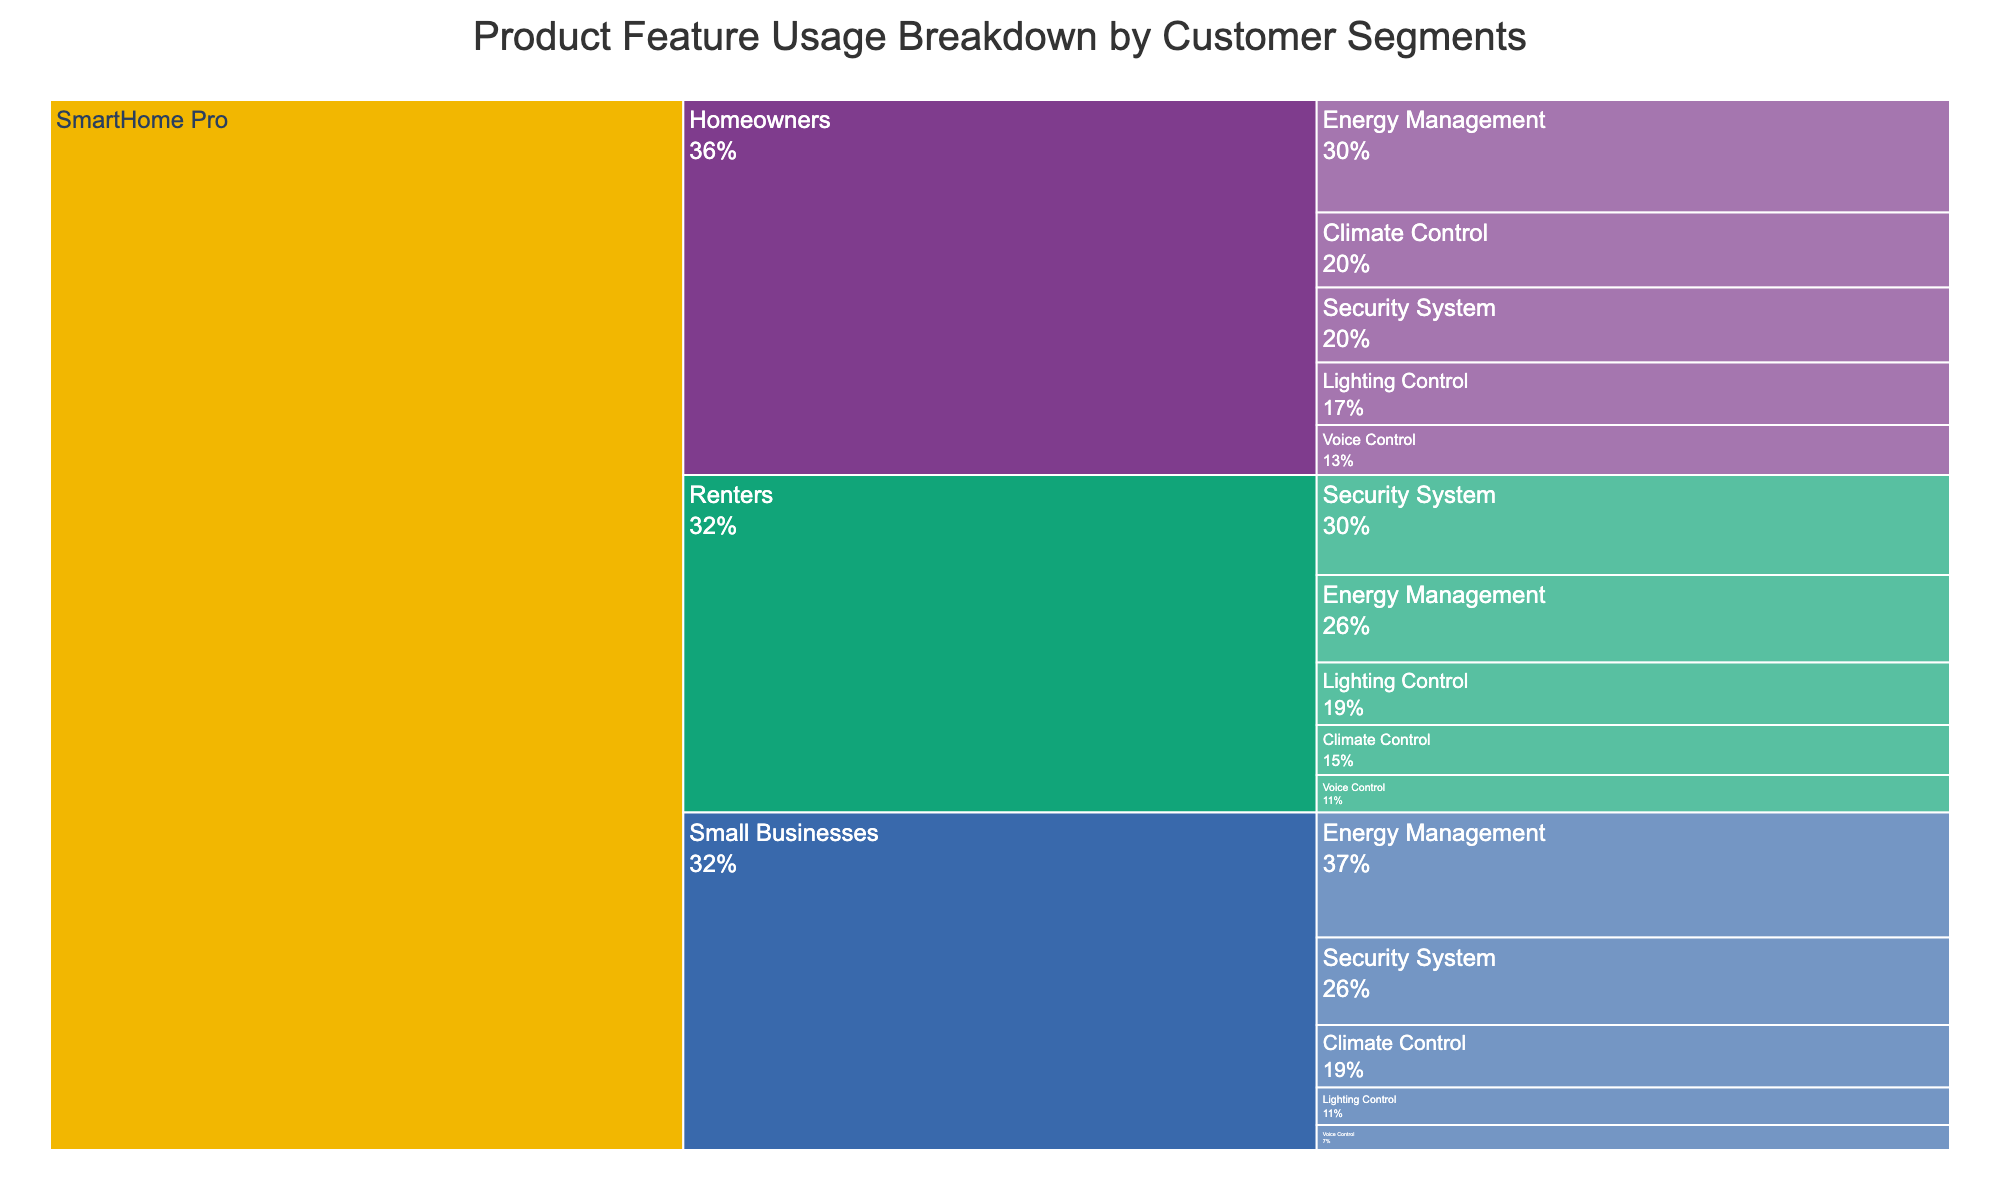What's the title of the chart? The title is usually displayed at the top of the chart and provides a summary of what the chart is about.
Answer: Product Feature Usage Breakdown by Customer Segments How many different segments are shown in the icicle chart? To determine the number of segments, count the different labeled branches directly under the product.
Answer: 3 Which feature has the highest usage among Small Businesses? Look for the segment labeled "Small Businesses" and then check the features under it to find the one with the highest value.
Answer: Energy Management What is the total usage of the Lighting Control feature across all segments? Sum the usage of the Lighting Control feature across all segments: Homeowners (25) + Renters (25) + Small Businesses (15).
Answer: 65 How does the usage of Security System compare between Homeowners and Renters? Find the branches for Security System under Homeowners and Renters and compare the values. Homeowners have 30 units of usage while Renters have 40 units.
Answer: Renters have more usage What's the percentage of Energy Management usage among Homeowners compared to the total usage of Homeowners? Find the total usage for Homeowners by summing all values (45 + 30 + 25 + 20 + 30), and then calculate the percentage of Energy Management (45/150).
Answer: 30% Which segment has the lowest usage of Voice Control feature? Examine the branches for Voice Control under each segment and identify the one with the lowest value.
Answer: Small Businesses What's the average usage of Climate Control feature across all segments? Find the Climate Control usage for each segment: Homeowners (30), Renters (20), Small Businesses (25). Calculate the average: (30 + 20 + 25) / 3.
Answer: 25 Is the sum of usage of Security System and Energy Management for Renters higher than the total usage of Lighting Control across all segments? Calculate the sum of Security System (40) and Energy Management (35) for Renters, then compare it with the total Lighting Control usage (65). 40 + 35 = 75, which is higher than 65.
Answer: Yes, it is higher 